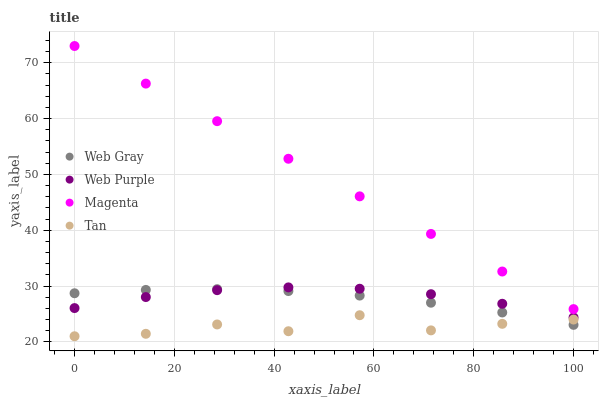Does Tan have the minimum area under the curve?
Answer yes or no. Yes. Does Magenta have the maximum area under the curve?
Answer yes or no. Yes. Does Web Gray have the minimum area under the curve?
Answer yes or no. No. Does Web Gray have the maximum area under the curve?
Answer yes or no. No. Is Magenta the smoothest?
Answer yes or no. Yes. Is Tan the roughest?
Answer yes or no. Yes. Is Web Gray the smoothest?
Answer yes or no. No. Is Web Gray the roughest?
Answer yes or no. No. Does Tan have the lowest value?
Answer yes or no. Yes. Does Web Gray have the lowest value?
Answer yes or no. No. Does Magenta have the highest value?
Answer yes or no. Yes. Does Web Gray have the highest value?
Answer yes or no. No. Is Tan less than Web Purple?
Answer yes or no. Yes. Is Web Purple greater than Tan?
Answer yes or no. Yes. Does Web Purple intersect Web Gray?
Answer yes or no. Yes. Is Web Purple less than Web Gray?
Answer yes or no. No. Is Web Purple greater than Web Gray?
Answer yes or no. No. Does Tan intersect Web Purple?
Answer yes or no. No. 